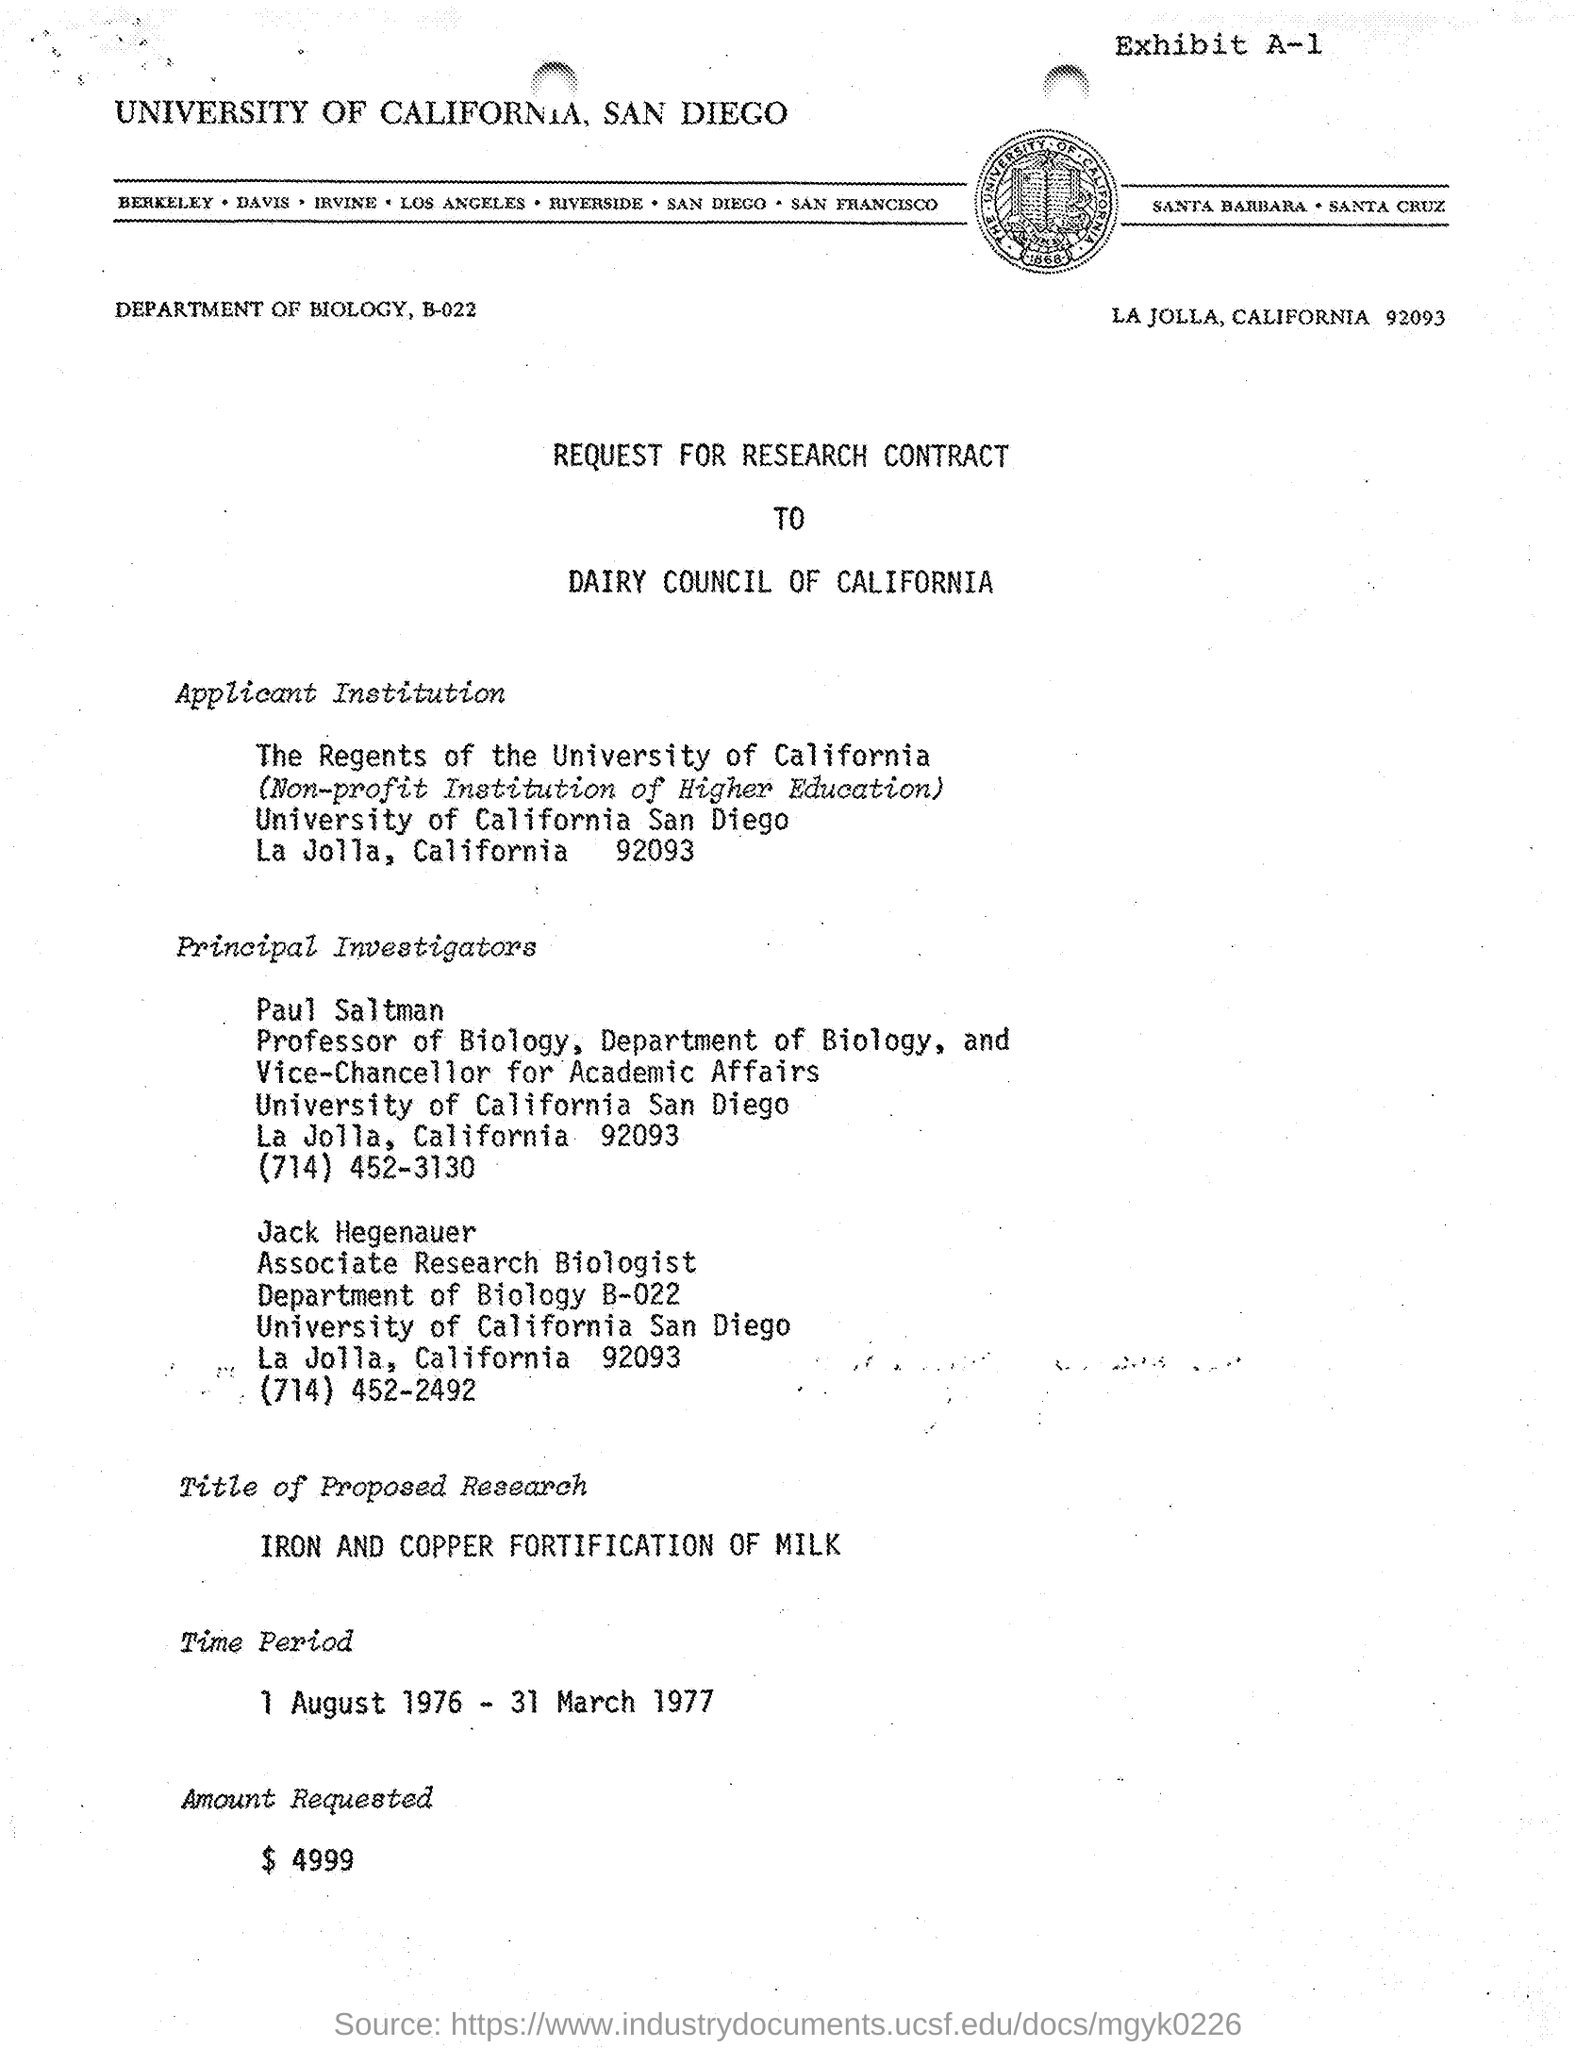Who is the Vice Chancellor for Academic Affairs, University of California - San Diego?
Offer a terse response. Paul Saltman. Which is the Applicant Institution given in the document?
Give a very brief answer. The Regents of the University of California. Which university is mentioned in the header of the document?
Ensure brevity in your answer.  UNIVERSITY OF CALIFORNIA, SAN DIEGO. What is the Amount Requested as per the document?
Offer a very short reply. $ 4999. What is the time period of the Research contract?
Provide a short and direct response. 1 August 1976 - 31 March 1977. 